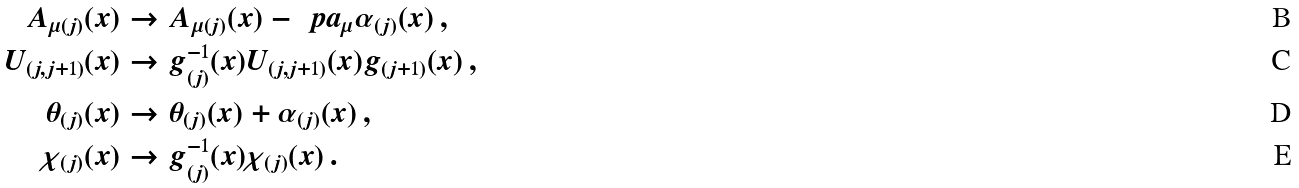Convert formula to latex. <formula><loc_0><loc_0><loc_500><loc_500>A _ { \mu ( j ) } ( x ) & \rightarrow A _ { \mu ( j ) } ( x ) - \ p a _ { \mu } \alpha _ { ( j ) } ( x ) \, , \\ U _ { ( j , j + 1 ) } ( x ) & \rightarrow g _ { ( j ) } ^ { - 1 } ( x ) U _ { ( j , j + 1 ) } ( x ) g _ { ( j + 1 ) } ( x ) \, , \\ \theta _ { ( j ) } ( x ) & \rightarrow \theta _ { ( j ) } ( x ) + \alpha _ { ( j ) } ( x ) \, , \\ \chi _ { ( j ) } ( x ) & \rightarrow g _ { ( j ) } ^ { - 1 } ( x ) \chi _ { ( j ) } ( x ) \, .</formula> 